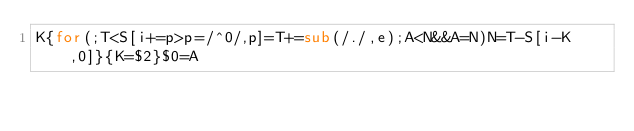Convert code to text. <code><loc_0><loc_0><loc_500><loc_500><_Awk_>K{for(;T<S[i+=p>p=/^0/,p]=T+=sub(/./,e);A<N&&A=N)N=T-S[i-K,0]}{K=$2}$0=A</code> 